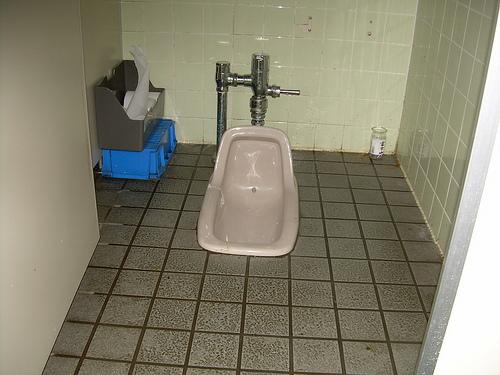Is this a 'western style' toilet?
Give a very brief answer. No. Is the toilet free standing?
Concise answer only. No. Does this toilet look clean enough to use?
Write a very short answer. Yes. 